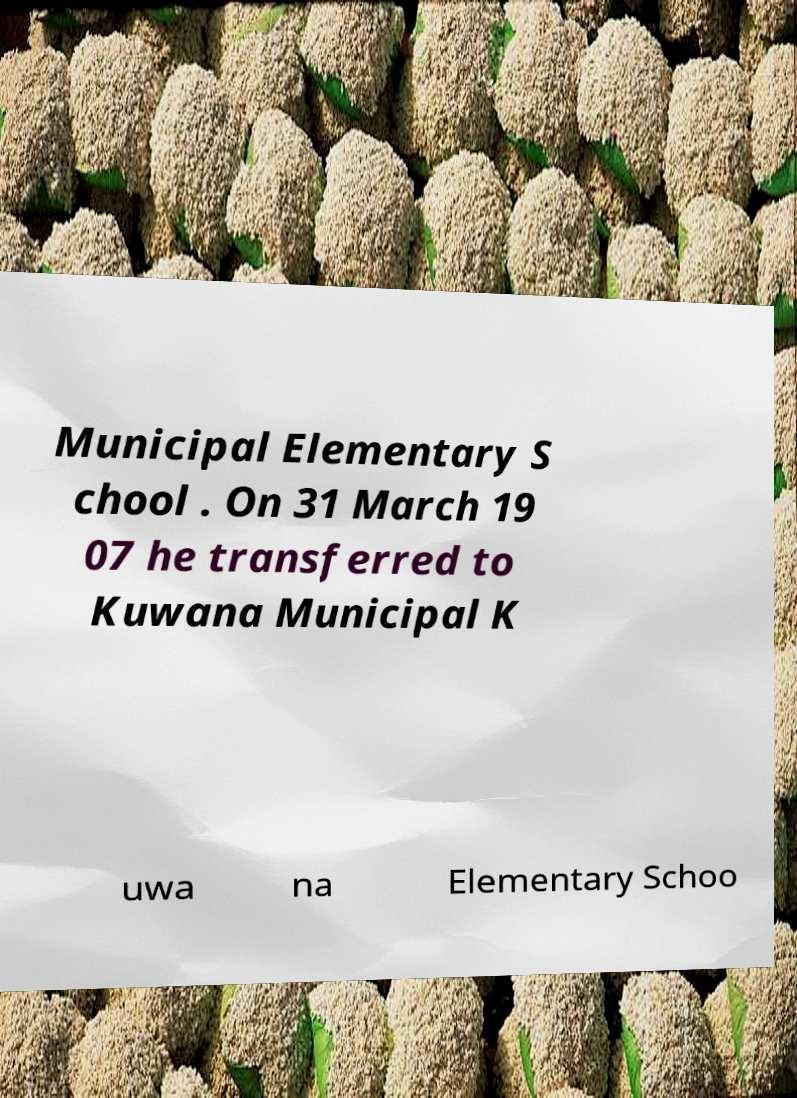For documentation purposes, I need the text within this image transcribed. Could you provide that? Municipal Elementary S chool . On 31 March 19 07 he transferred to Kuwana Municipal K uwa na Elementary Schoo 